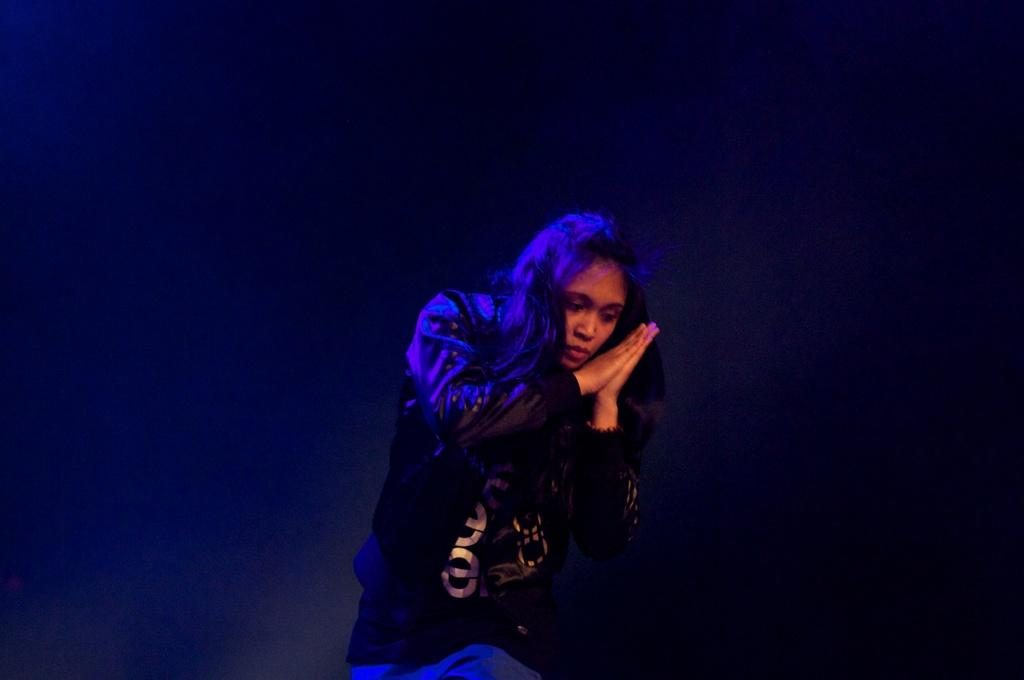What is the main subject of the image? There is a person standing in the image. What is the person doing with her hands? The person is holding her palms. Can you describe the background of the image? The background of the image is dark. What substance is the person holding in her hands? There is no substance visible in the person's hands in the image; she is simply holding her palms. 